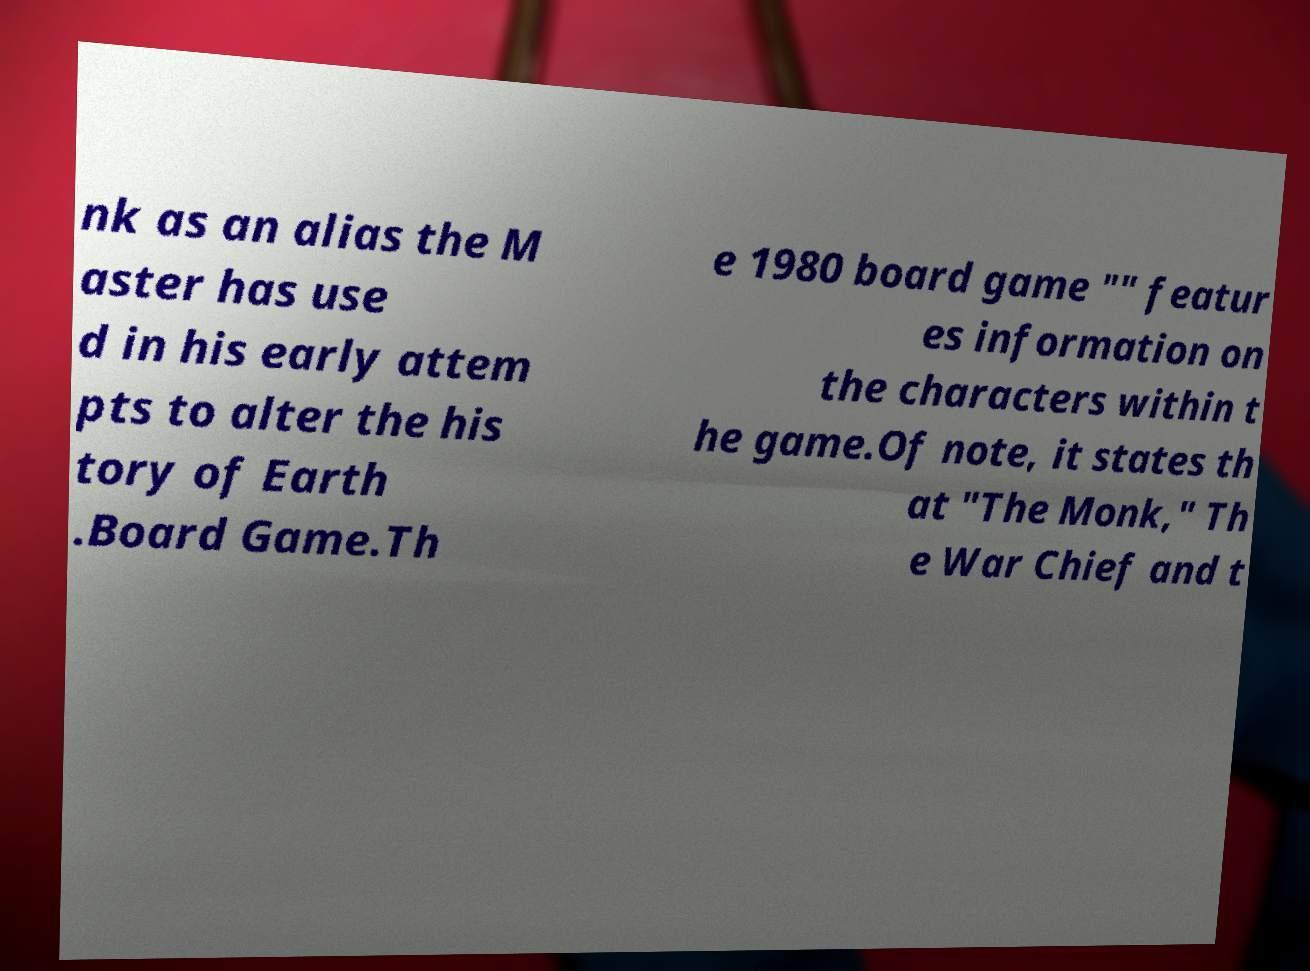For documentation purposes, I need the text within this image transcribed. Could you provide that? nk as an alias the M aster has use d in his early attem pts to alter the his tory of Earth .Board Game.Th e 1980 board game "" featur es information on the characters within t he game.Of note, it states th at "The Monk," Th e War Chief and t 